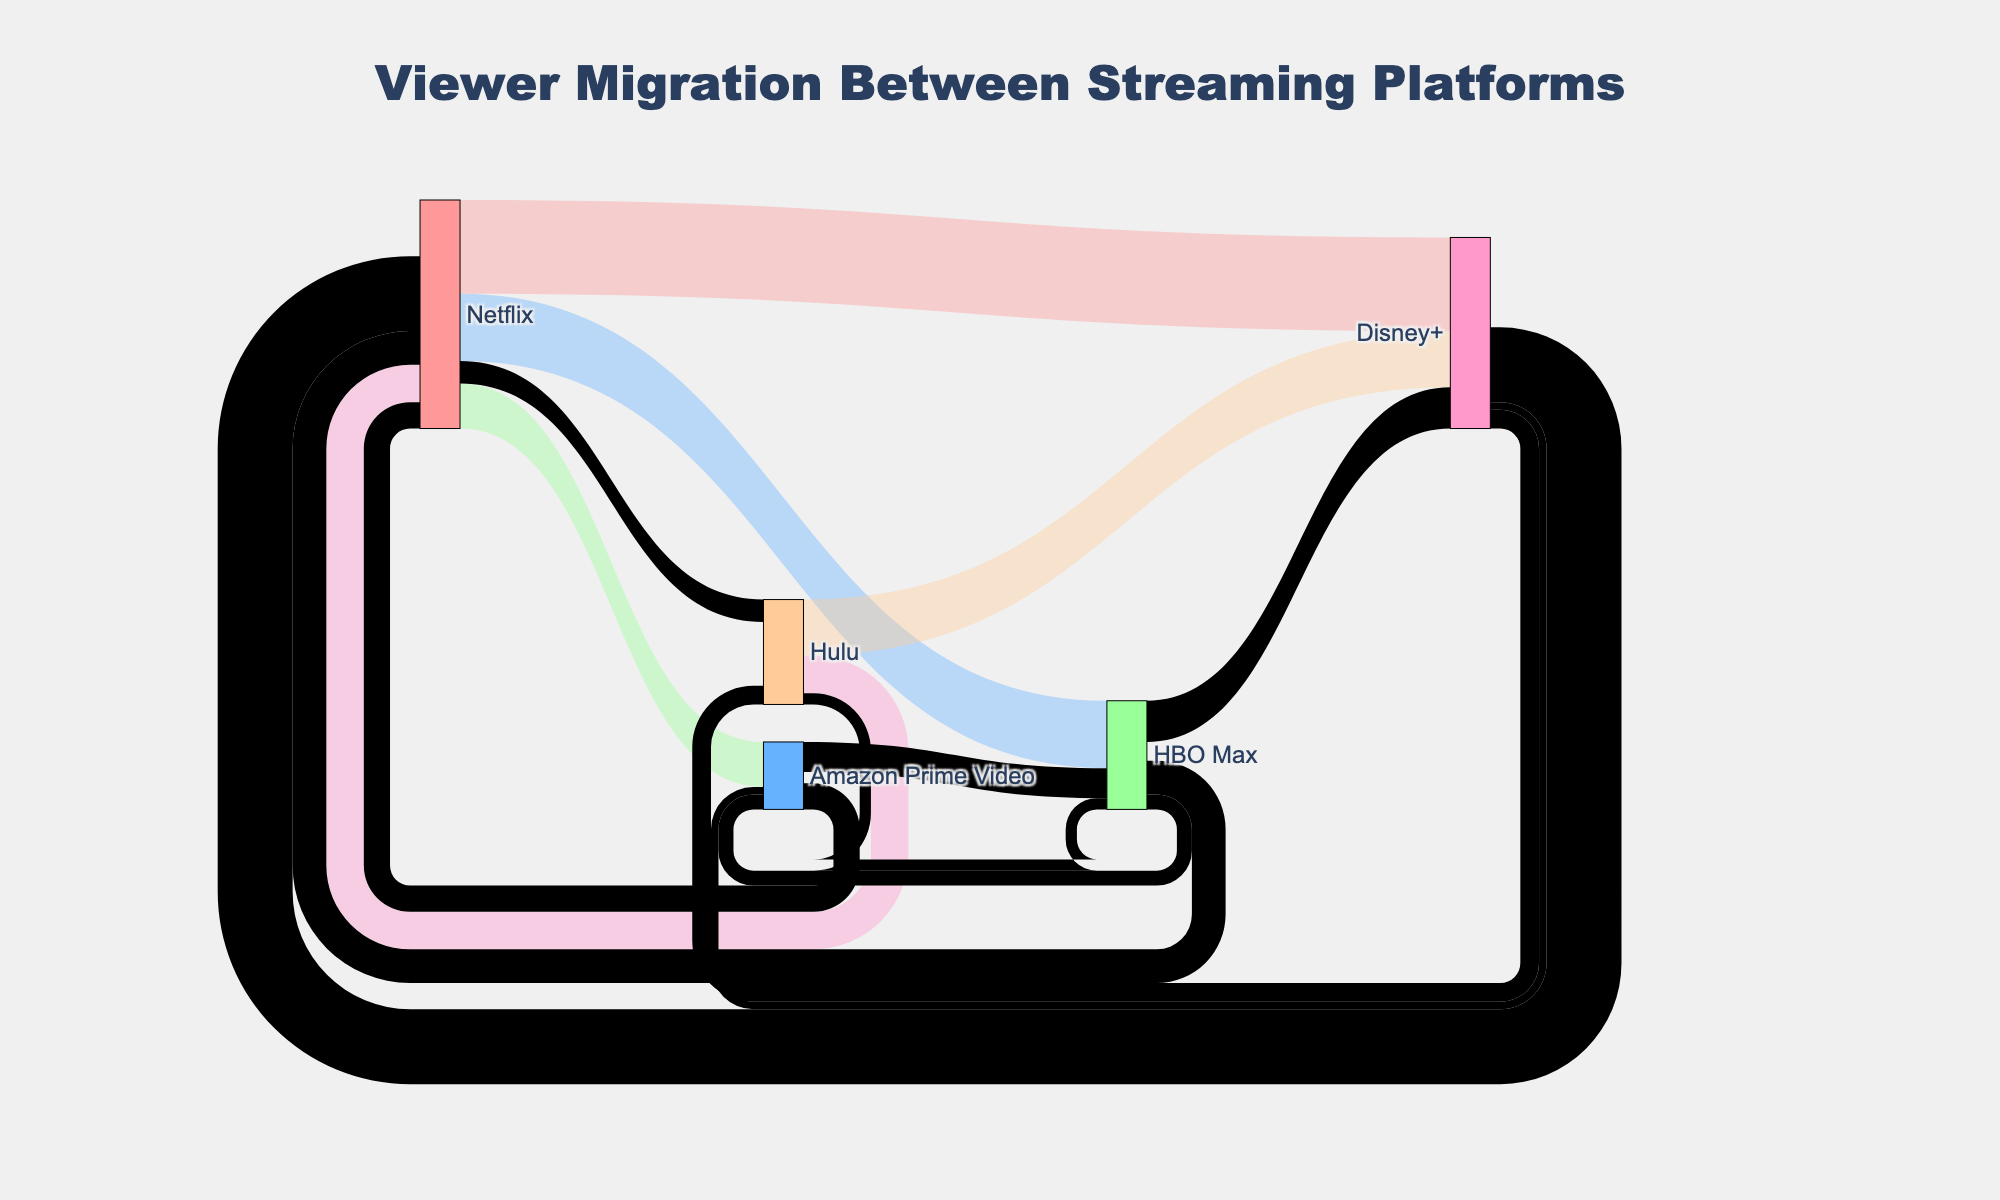Which streaming platform has the highest viewer migration from Netflix? From the Sankey Diagram, we observe that the bar for Disney+ migrating from Netflix is the largest, indicating the highest number of viewers. Hence, by directly comparing the lengths of the flows originating from Netflix, it is clear that Disney+ has the highest migration.
Answer: Disney+ What is the total number of viewers migrating to Disney+ from other platforms? To find the total number of viewers migrating to Disney+, we sum all the values of the flows pointing towards Disney+: Netflix (250,000) + Hulu (150,000) + HBO Max (110,000) = 510,000.
Answer: 510,000 How does the viewer migration from Disney+ to other platforms compare to the migration from HBO Max to other platforms? We sum the outgoing migrations for both platforms: Disney+: Netflix (200,000) + Hulu (50,000) + Amazon Prime (20,000) = 270,000; HBO Max: Disney+ (110,000) + Netflix (90,000) + Amazon Prime (40,000) = 240,000. Comparatively, Disney+ has a higher total migration to other platforms than HBO Max.
Answer: Disney+ has a higher total migration Which platform has more viewers migrating to Netflix: Disney+ or HBO Max? By comparing the values of flows pointing towards Netflix: Disney+ to Netflix (200,000) and HBO Max to Netflix (90,000). Disney+ has more viewers migrating to Netflix than HBO Max.
Answer: Disney+ What is the smallest migration value between any two platforms? By examining all values shown in the Sankey Diagram, the smallest flow is from Disney+ to Amazon Prime Video with 20,000 viewers.
Answer: 20,000 What is the combined migration of viewers from Amazon Prime Video and Hulu to HBO Max? We sum the migration values from Amazon Prime Video (80,000) and Hulu (30,000) to HBO Max: 80,000 + 30,000 = 110,000.
Answer: 110,000 Which platform receives the second-highest volume of migrating viewers from other platforms? By examining the incoming flows to all platforms, Netflix has the highest migration (total 460,000), followed by Disney+ with the second highest (510,000). Hence, the second-highest is Disney+.
Answer: Disney+ Is there a platform that both gains and loses viewers to Netflix? If so, which? By checking the paths in the Sankey Diagram, both Disney+ and HBO Max have viewer flows to and from Netflix.
Answer: Disney+ and HBO Max What is the total viewer migration between Netflix and Hulu in both directions? Viewer migration from Netflix to Hulu is 60,000 and from Hulu to Netflix is 100,000. Summing them: 60,000 + 100,000 = 160,000.
Answer: 160,000 